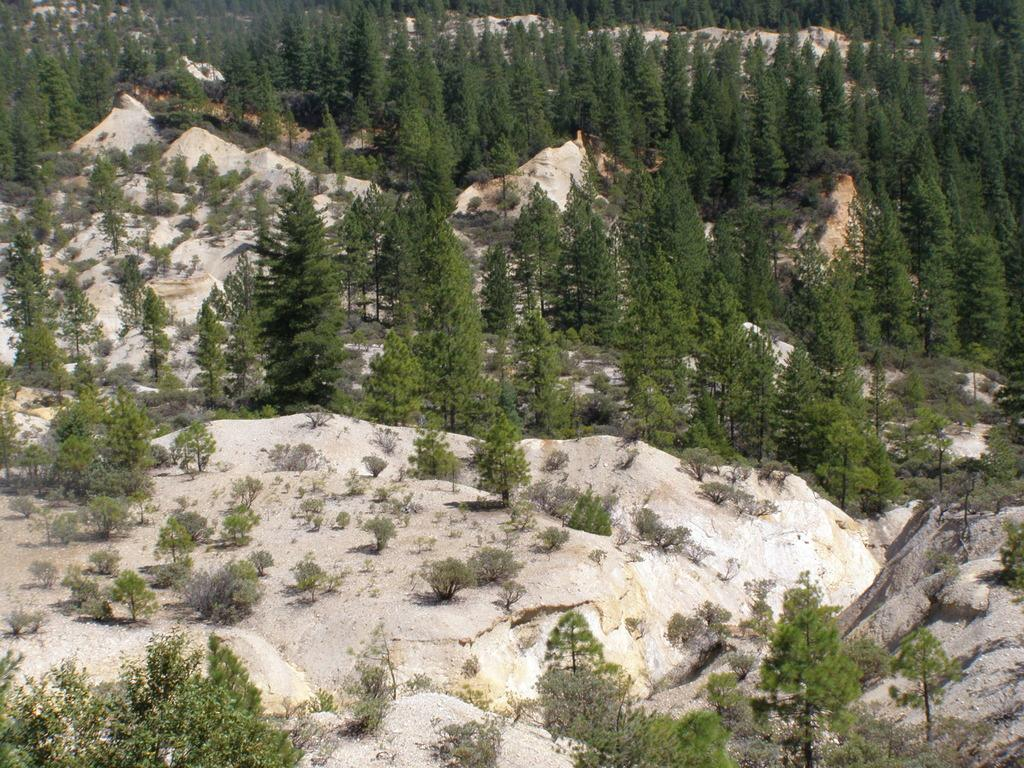What type of natural elements can be seen in the image? There are rocks and trees in the image. Can you describe the rocks in the image? The rocks in the image are likely solid, natural formations. What type of vegetation is present in the image? There are trees in the image. What is the price of the rock in the image? There is no price associated with the rock in the image, as it is a natural formation and not a product for sale. 